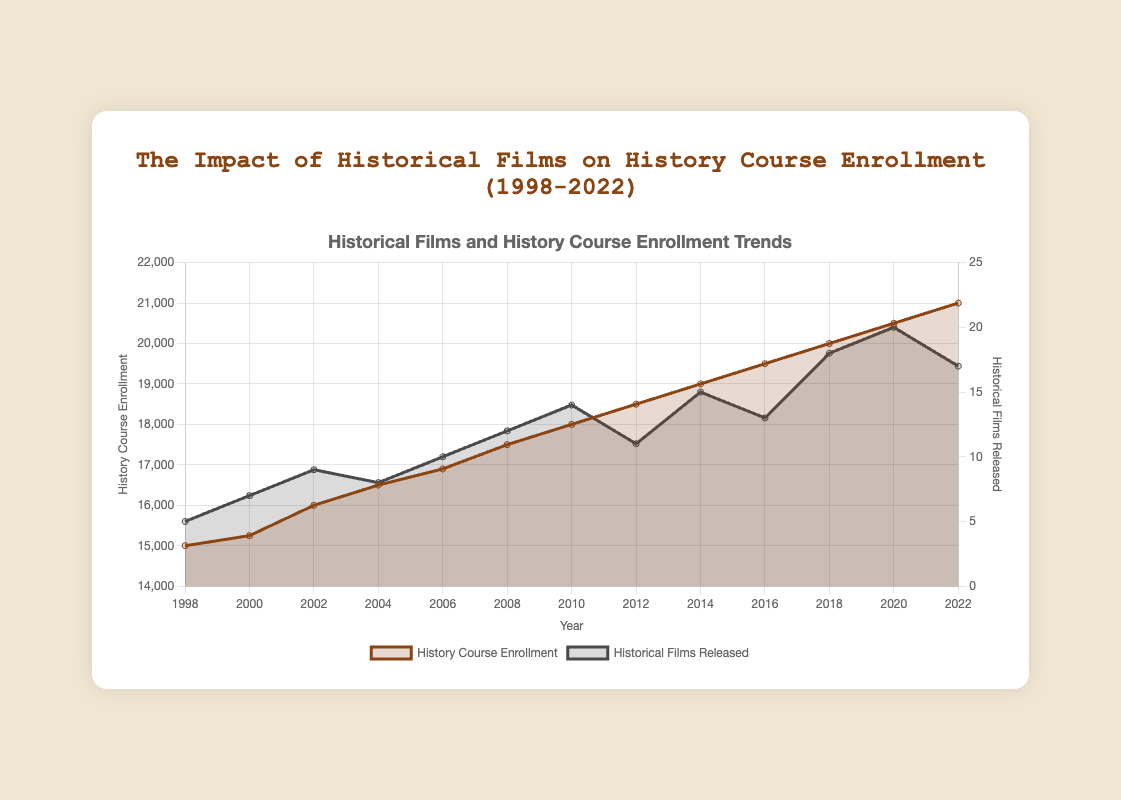What is the title of the figure? The title of the figure is displayed at the top, which clearly states the main subject of the chart. The title provides a quick overview of the chart's purpose.
Answer: The Impact of Historical Films on History Course Enrollment (1998-2022) How many historical films were released in 2018? The data for the number of historical films released is indicated by one of the filled areas corresponding to each year. By finding the year 2018 along the x-axis and tracing upwards, we see the number of historical films released.
Answer: 18 How did the history course enrollment change from 1998 to 2000? To determine the change, we find the enrollment values for 1998 and 2000 on the y-axis and subtract the earlier year's value from the later year's value. Enrollment in 1998 was 15,000, and in 2000, it was 15,250. So, 15,250 - 15,000 is 250.
Answer: It increased by 250 What is the general trend of historical films released from 2000 to 2006? Reviewing the plot, we trace the number of historical films released from 2000 to 2006. In 2000, 7 films were released, and in 2006, it increased to 10. The numbers generally increase over this period.
Answer: Increasing trend Which year had the highest history course enrollment? By inspecting the highest point of the history course enrollment area, we can identify the year with the maximum value on the y-axis on the left. The peak enrollment happens in the year 2022.
Answer: 2022 What is the difference in the number of historical films released between 2020 and 2022? The number of films released in 2020 was 20, and in 2022, it was 17. To find the difference, subtract the smaller number from the larger number, i.e., 20 - 17.
Answer: 3 How did the trend of history course enrollment compare to the trend of historical films released from 2008 to 2010? Observing the plot, both trends can be compared visually. From 2008 to 2010, the enrollment steadily rises from 17,500 to 18,000, while the number of films released also rises from 12 to 14.
Answer: Both trended upwards What is the overall trend in history course enrollment over the entire period from 1998 to 2022? Looking at the data points on the chart from 1998 to 2022, the course enrollment consistently increases, indicating a positive upward trend throughout the period.
Answer: Increasing trend Which year showed a decrease in historical films released after a previous peak? Find the highest points and then trace the following year to observe if there was any decrease. In 2018, 18 films were released, and in 2019, the number of released films fell to 17.
Answer: 2022 What impact can be inferred regarding the relationship between releasing historical films and history course enrollments? Based on an overall rising trend in both variables, it can be inferred that there might be a positive correlation, where increasing the release of historical films seems to coincide with rising history course enrollments.
Answer: Positive correlation 